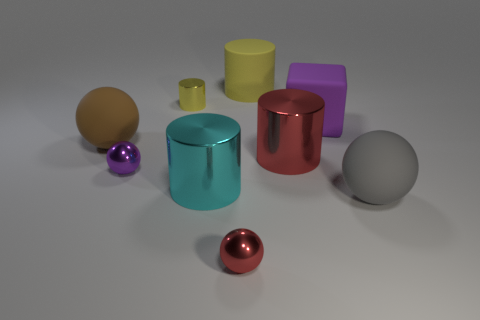What color is the object to the right of the big purple matte object?
Ensure brevity in your answer.  Gray. How many large purple matte cubes are in front of the big rubber ball left of the small shiny thing that is behind the large purple matte thing?
Keep it short and to the point. 0. There is a tiny object that is both right of the purple shiny thing and in front of the large brown object; what material is it made of?
Ensure brevity in your answer.  Metal. Do the tiny yellow cylinder and the purple thing in front of the purple block have the same material?
Your answer should be compact. Yes. Is the number of purple metallic balls that are right of the small yellow object greater than the number of metallic things behind the big cyan metallic cylinder?
Ensure brevity in your answer.  No. The big cyan metallic thing has what shape?
Your answer should be very brief. Cylinder. Does the red thing left of the large yellow matte thing have the same material as the cylinder in front of the small purple object?
Ensure brevity in your answer.  Yes. There is a yellow object to the right of the small yellow metallic thing; what shape is it?
Provide a succinct answer. Cylinder. There is a gray thing that is the same shape as the large brown object; what is its size?
Provide a short and direct response. Large. Is the tiny cylinder the same color as the big matte cube?
Keep it short and to the point. No. 